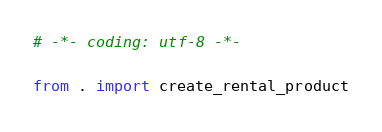<code> <loc_0><loc_0><loc_500><loc_500><_Python_># -*- coding: utf-8 -*-

from . import create_rental_product
</code> 